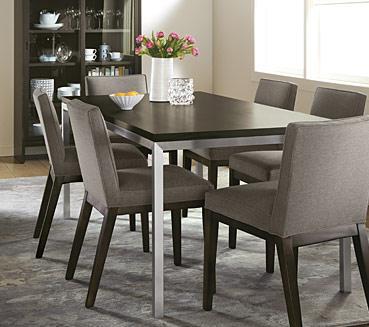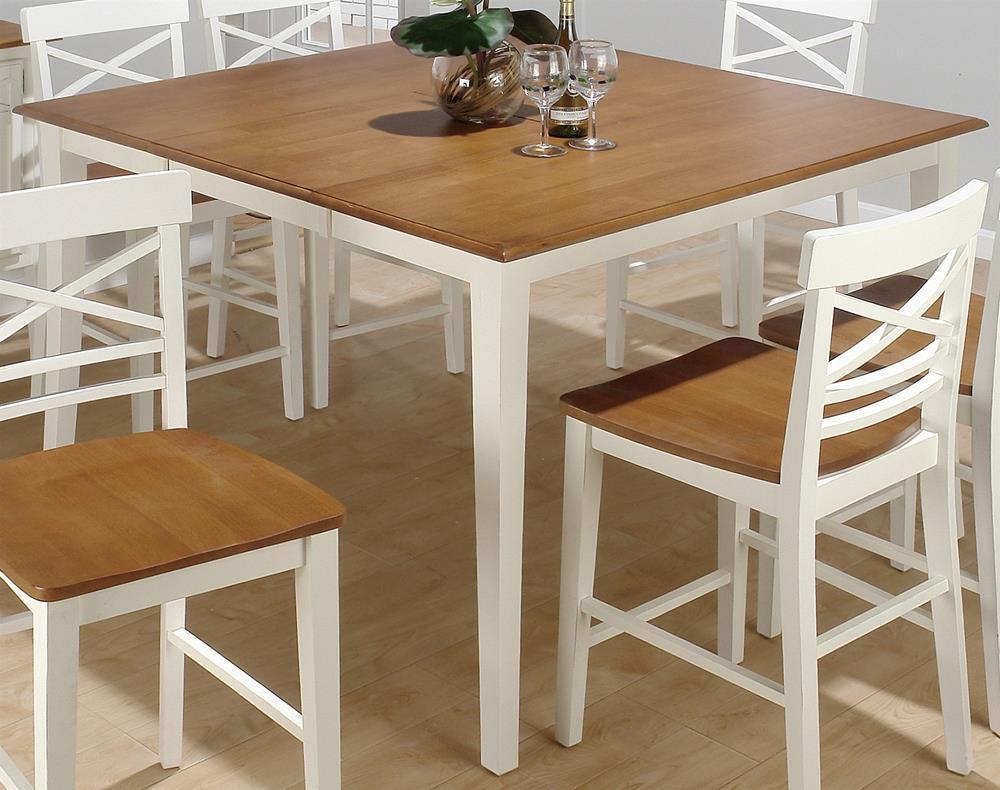The first image is the image on the left, the second image is the image on the right. Analyze the images presented: Is the assertion "There is a white hanging lamp over the table in at least one of the images." valid? Answer yes or no. No. The first image is the image on the left, the second image is the image on the right. Assess this claim about the two images: "A dining set features a dark table top and four-legged chairs with solid, monochrome backs and seats.". Correct or not? Answer yes or no. Yes. 